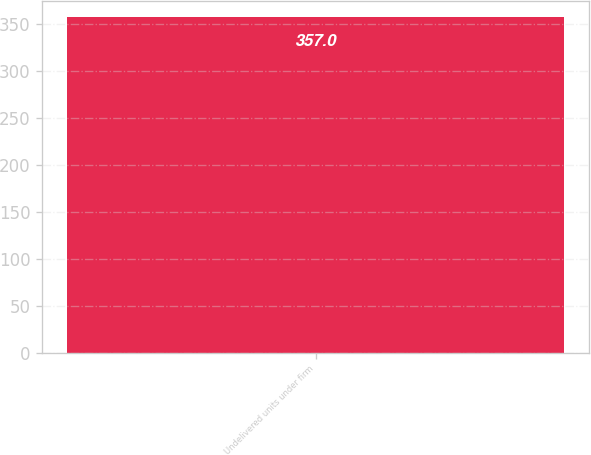<chart> <loc_0><loc_0><loc_500><loc_500><bar_chart><fcel>Undelivered units under firm<nl><fcel>357<nl></chart> 